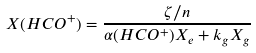<formula> <loc_0><loc_0><loc_500><loc_500>X ( H C O ^ { + } ) = \frac { \zeta / n } { \alpha ( H C O ^ { + } ) X _ { e } + k _ { g } X _ { g } }</formula> 